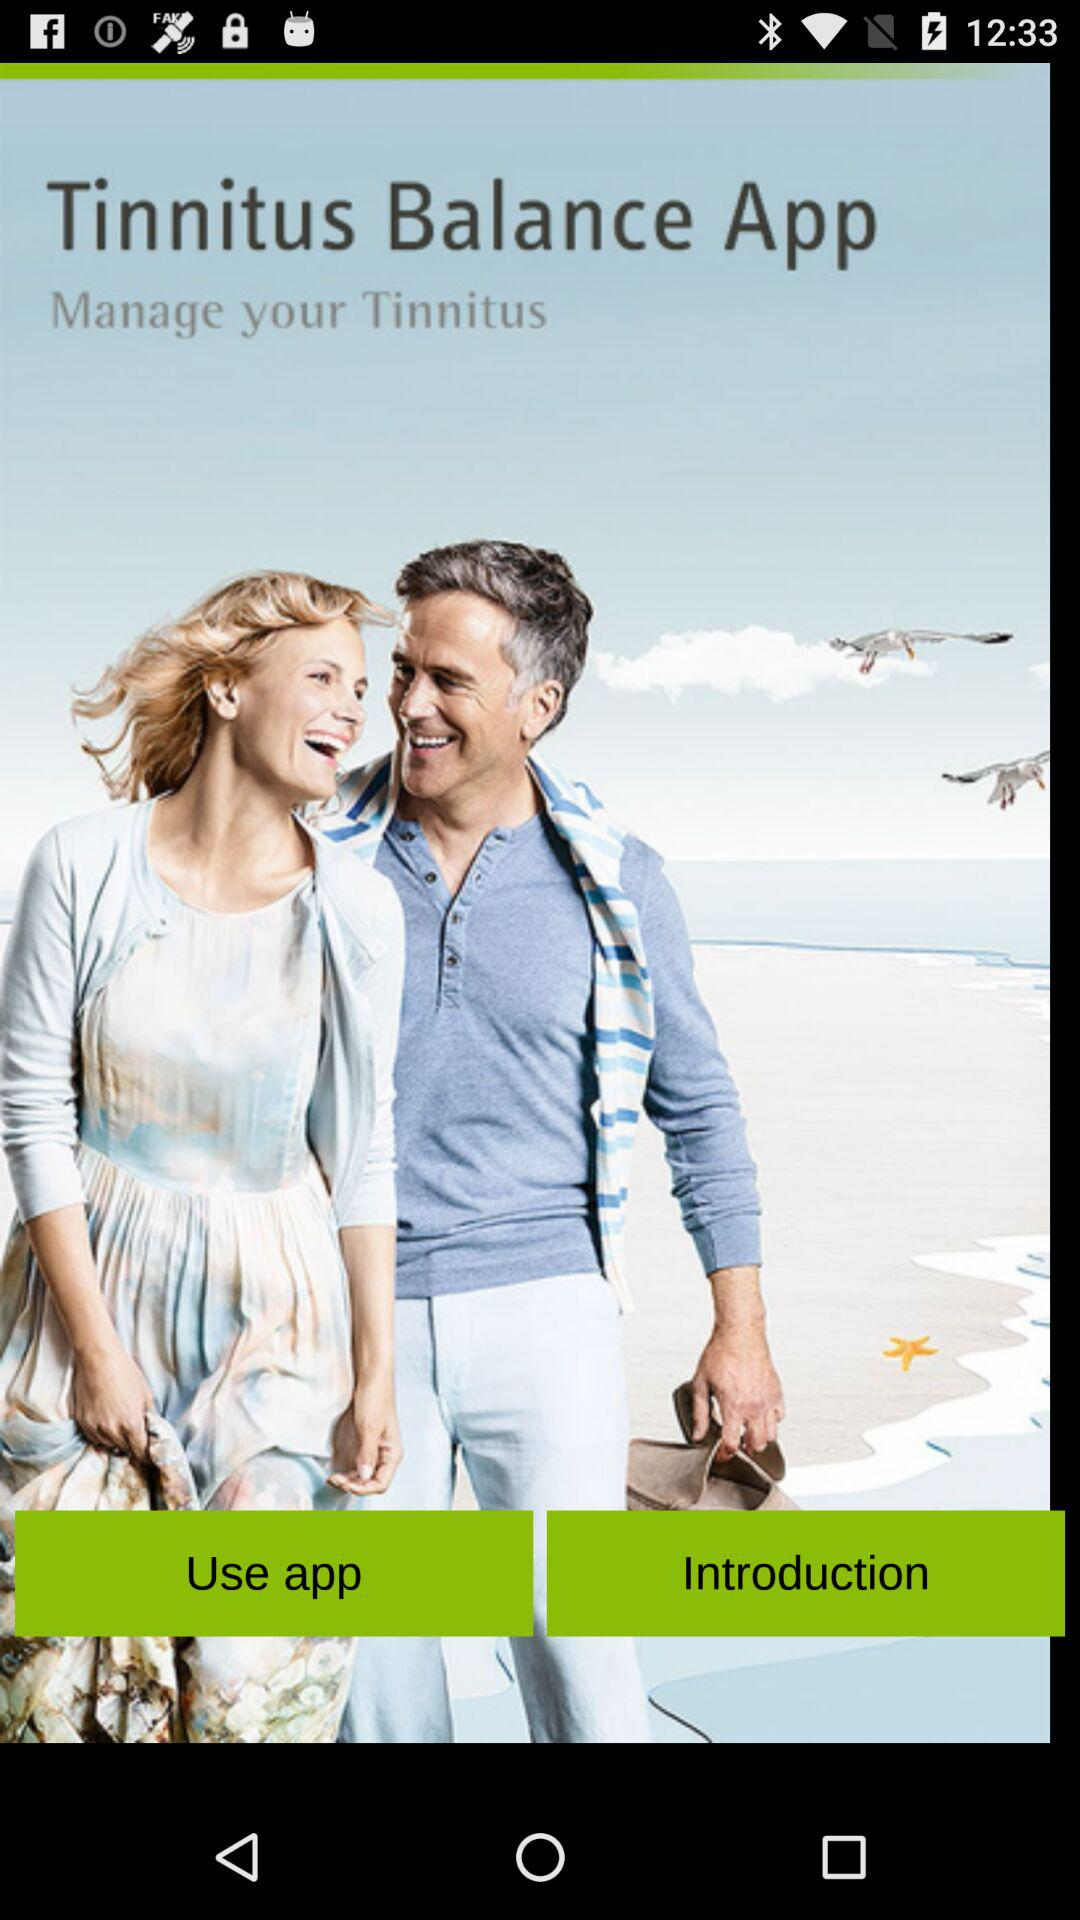What is the name of the application? The name of the application is "Tinnitus Balance". 